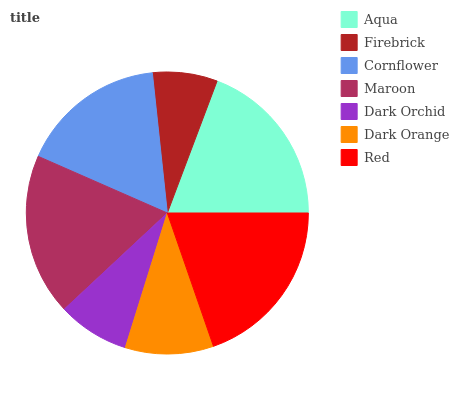Is Firebrick the minimum?
Answer yes or no. Yes. Is Red the maximum?
Answer yes or no. Yes. Is Cornflower the minimum?
Answer yes or no. No. Is Cornflower the maximum?
Answer yes or no. No. Is Cornflower greater than Firebrick?
Answer yes or no. Yes. Is Firebrick less than Cornflower?
Answer yes or no. Yes. Is Firebrick greater than Cornflower?
Answer yes or no. No. Is Cornflower less than Firebrick?
Answer yes or no. No. Is Cornflower the high median?
Answer yes or no. Yes. Is Cornflower the low median?
Answer yes or no. Yes. Is Dark Orange the high median?
Answer yes or no. No. Is Dark Orchid the low median?
Answer yes or no. No. 